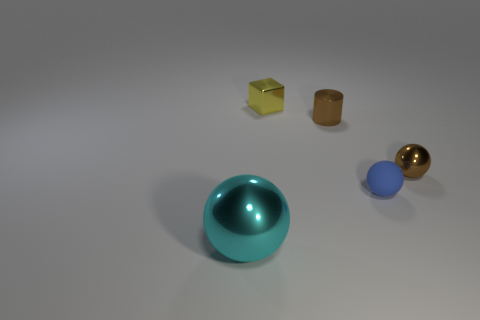What is the material of the tiny thing that is the same color as the small cylinder?
Provide a succinct answer. Metal. Is the number of blue balls to the left of the large sphere less than the number of small shiny objects?
Keep it short and to the point. Yes. Is the material of the cyan sphere the same as the tiny brown cylinder behind the brown shiny ball?
Ensure brevity in your answer.  Yes. What material is the big cyan sphere?
Give a very brief answer. Metal. The sphere that is behind the tiny sphere to the left of the metal sphere right of the large cyan metal object is made of what material?
Make the answer very short. Metal. There is a small matte ball; does it have the same color as the sphere that is left of the tiny blue rubber ball?
Provide a short and direct response. No. Is there any other thing that is the same shape as the large shiny object?
Make the answer very short. Yes. The tiny ball that is left of the metal sphere to the right of the big sphere is what color?
Offer a very short reply. Blue. How many matte objects are there?
Your response must be concise. 1. What number of metal things are tiny blue balls or cylinders?
Offer a terse response. 1. 